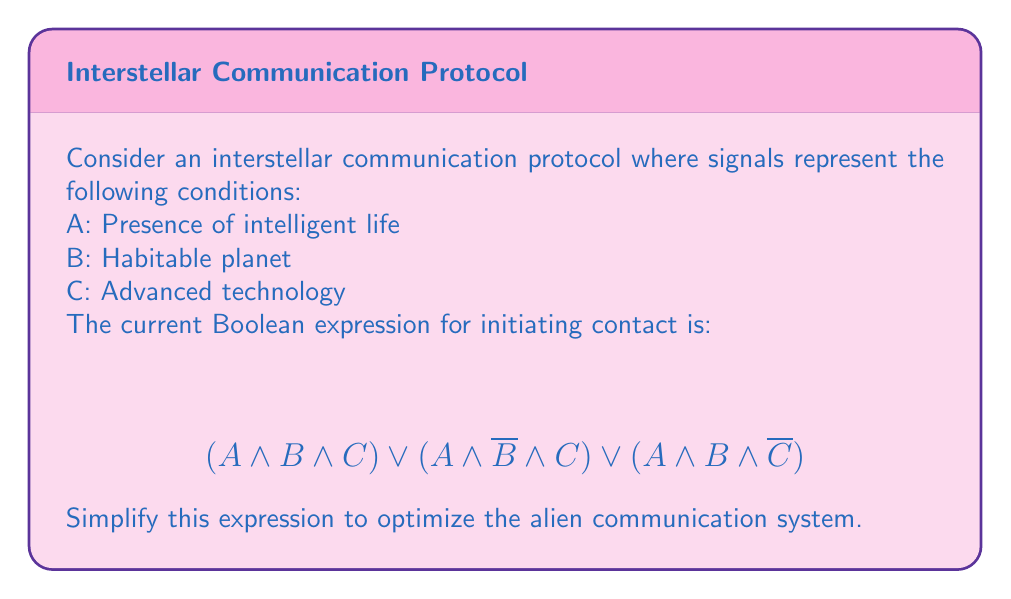Provide a solution to this math problem. Let's simplify this Boolean expression step by step:

1) First, we can factor out $A$ from all terms:
   $A \land [(B \land C) \lor (\overline{B} \land C) \lor (B \land \overline{C})]$

2) Now, let's focus on the expression inside the square brackets:
   $(B \land C) \lor (\overline{B} \land C) \lor (B \land \overline{C})$

3) We can use the distributive law to factor out $C$ from the first two terms:
   $[C \land (B \lor \overline{B})] \lor (B \land \overline{C})$

4) $B \lor \overline{B}$ is always true (law of excluded middle), so we can simplify:
   $(C \land 1) \lor (B \land \overline{C})$

5) $C \land 1 = C$, so we have:
   $C \lor (B \land \overline{C})$

6) This expression is in the form of $X \lor (Y \land \overline{X})$, which simplifies to $X \lor Y$ (absorption law)
   So, $C \lor (B \land \overline{C})$ simplifies to $C \lor B$

7) Putting this back into our original expression:
   $A \land (B \lor C)$

This is our final simplified expression.
Answer: $A \land (B \lor C)$ 